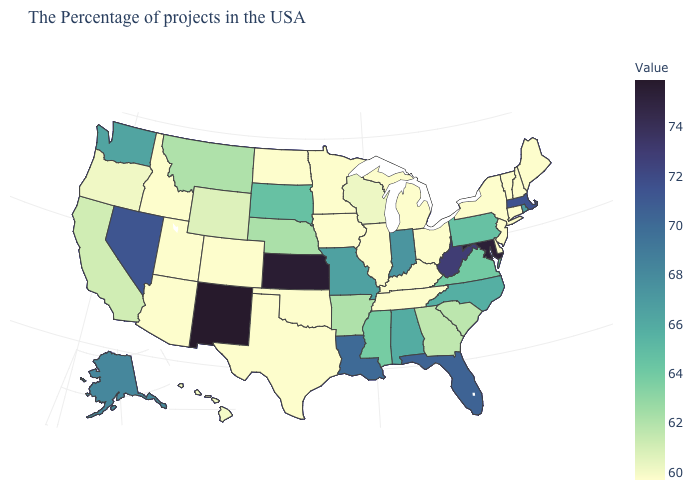Does Michigan have the lowest value in the MidWest?
Give a very brief answer. Yes. Which states have the lowest value in the USA?
Quick response, please. Maine, New Hampshire, Vermont, Connecticut, New York, New Jersey, Delaware, Ohio, Michigan, Kentucky, Tennessee, Illinois, Minnesota, Iowa, Oklahoma, Texas, North Dakota, Colorado, Utah, Arizona, Idaho. Is the legend a continuous bar?
Keep it brief. Yes. Does Michigan have the lowest value in the USA?
Concise answer only. Yes. Does South Dakota have a higher value than Maryland?
Quick response, please. No. Which states hav the highest value in the MidWest?
Quick response, please. Kansas. Which states have the highest value in the USA?
Answer briefly. New Mexico. 